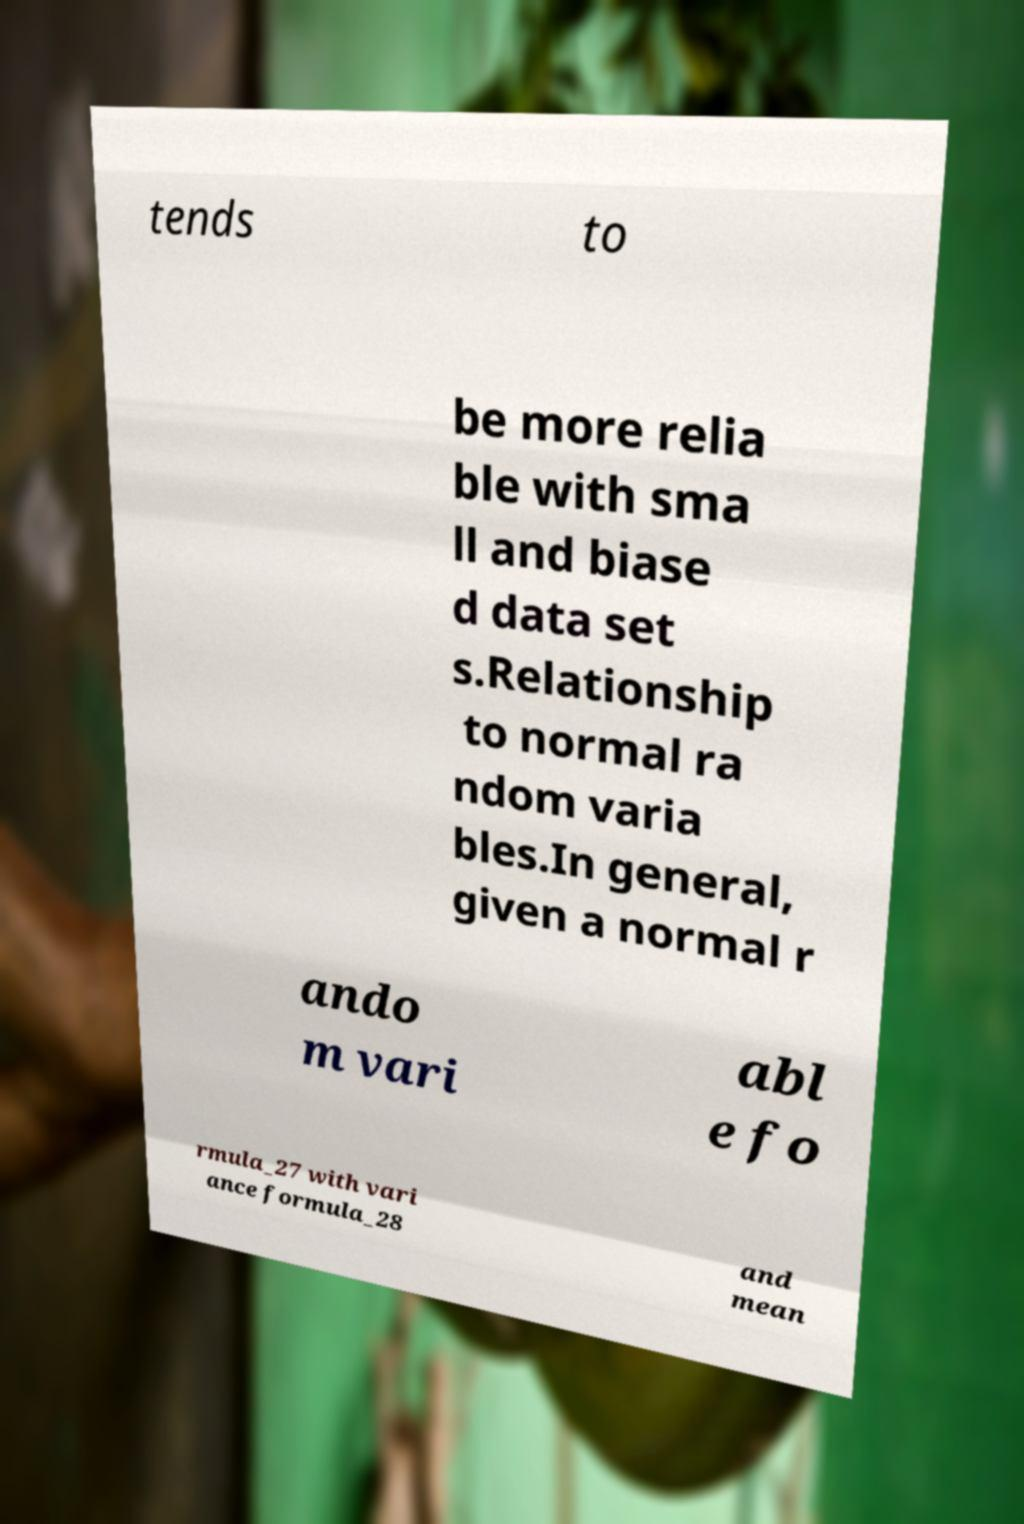I need the written content from this picture converted into text. Can you do that? tends to be more relia ble with sma ll and biase d data set s.Relationship to normal ra ndom varia bles.In general, given a normal r ando m vari abl e fo rmula_27 with vari ance formula_28 and mean 